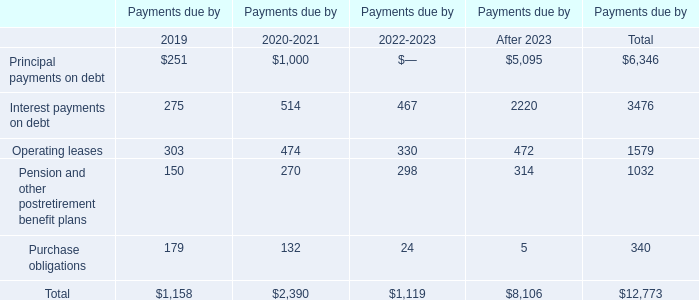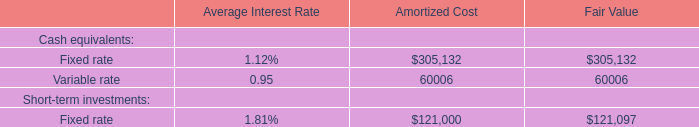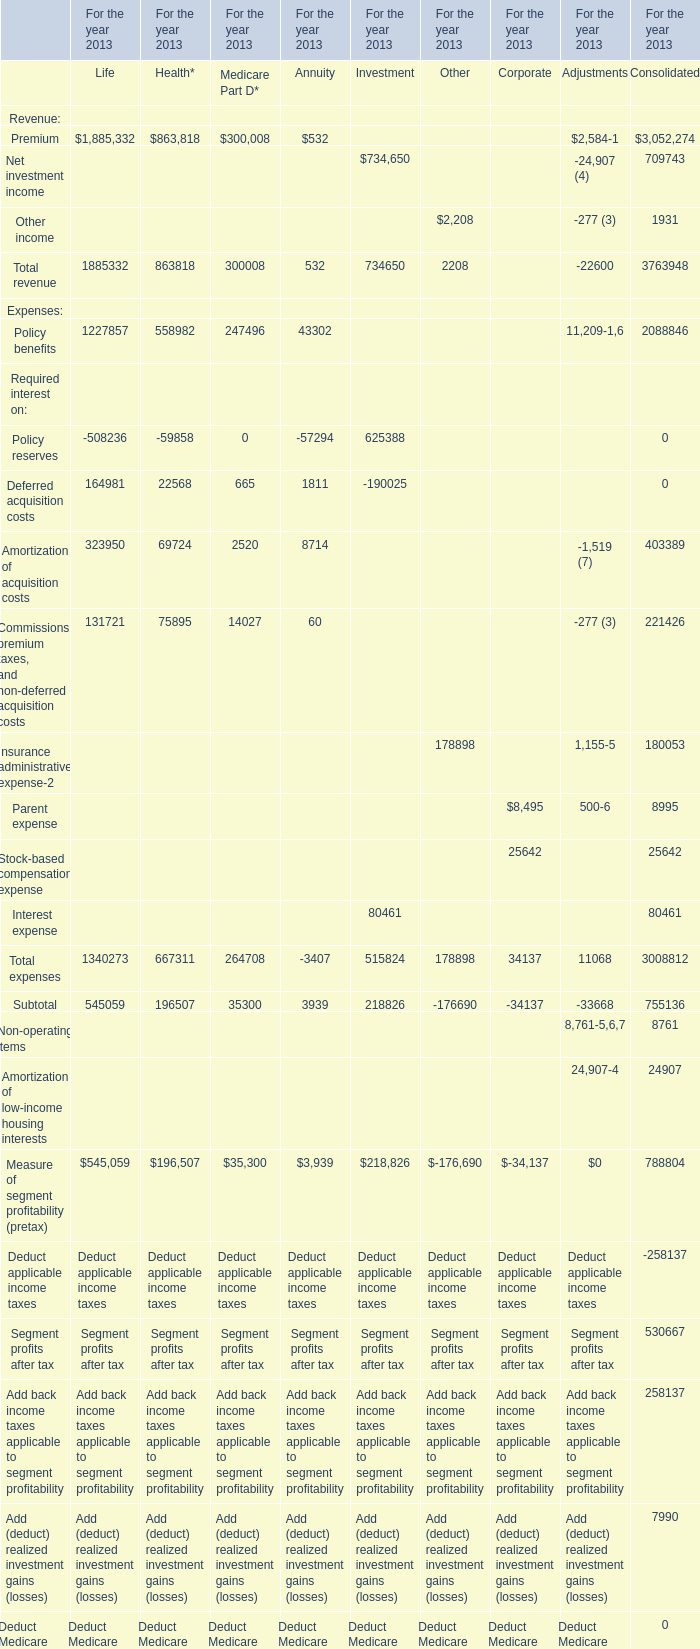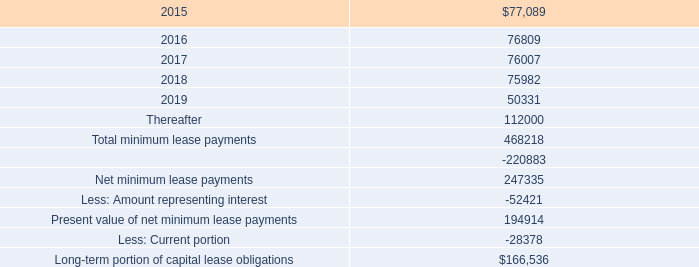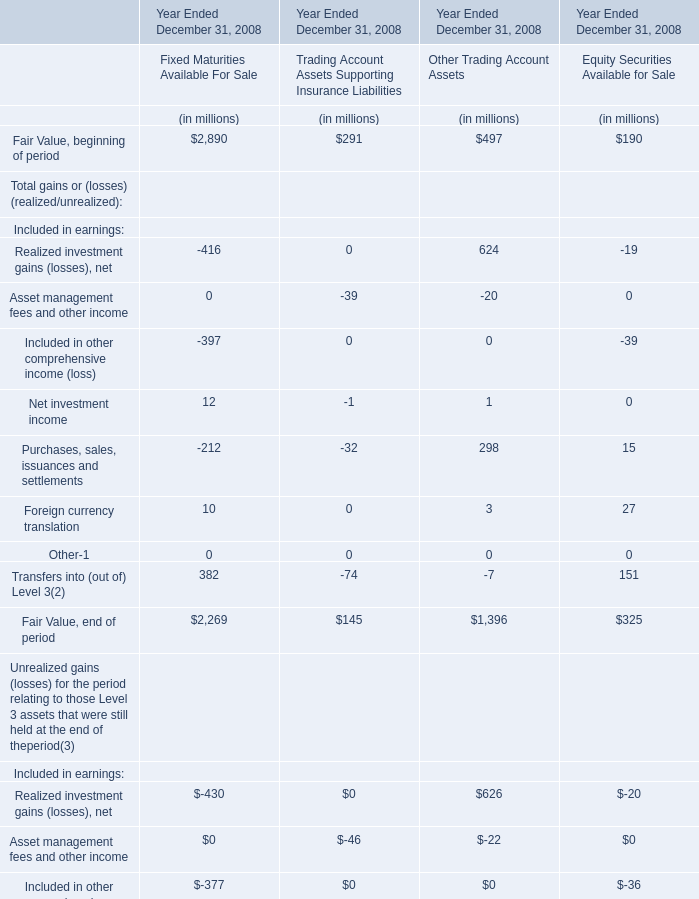What is the 40% of the Total revenue of Life for the year 2013? 
Computations: (1885332 * 0.4)
Answer: 754132.8. 